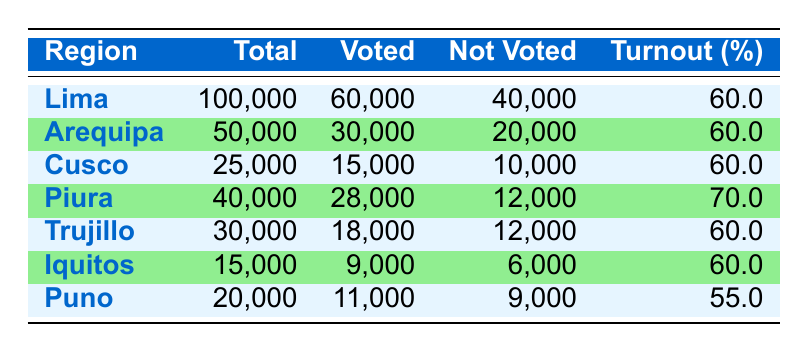What is the voter turnout percentage in Lima? According to the table, Lima has a voter turnout percentage of 60.0%. This value is listed in the column labeled "Turnout (%)" across from the region "Lima".
Answer: 60.0% How many first-time voters in Arequipa did not vote? The table indicates that there were 20,000 voters who did not vote in Arequipa, as specified in the "Not Voted" column for that region.
Answer: 20,000 What region had the highest voter turnout? By comparing the "Turnout (%)" values, Piura has the highest percentage at 70.0%, which is greater than the percentages of other regions in the table.
Answer: Piura What is the total number of first-time voters across all regions? To find the total number of first-time voters, add the "Total" values from each row: (100,000 + 50,000 + 25,000 + 40,000 + 30,000 + 15,000 + 20,000) = 280,000. Thus, the total is 280,000.
Answer: 280,000 Is it true that the voter turnout in Puno is less than that in Trujillo? In Puno, the turnout is 55.0%, while Trujillo has a turnout of 60.0%. Since 55.0% is less than 60.0%, the statement is true.
Answer: True What is the average voter turnout percentage among the regions listed? To calculate the average, sum the turnout percentages (60.0 + 60.0 + 60.0 + 70.0 + 60.0 + 60.0 + 55.0) = 425.0, and then divide by the number of regions (7): 425.0 / 7 = 60.71, the average is approximately 60.71%.
Answer: 60.71% How many more first-time voters voted in Piura than in Iquitos? The number of voters in Piura is 28,000 while in Iquitos it is 9,000. The difference is calculated by subtracting Iquitos' voters from Piura's: 28,000 - 9,000 = 19,000, so 19,000 more voters voted in Piura.
Answer: 19,000 Which region had the least number of voters? By examining the "Total" column, Iquitos has the least number of total first-time voters with only 15,000, which is lower than all other regions listed.
Answer: Iquitos 